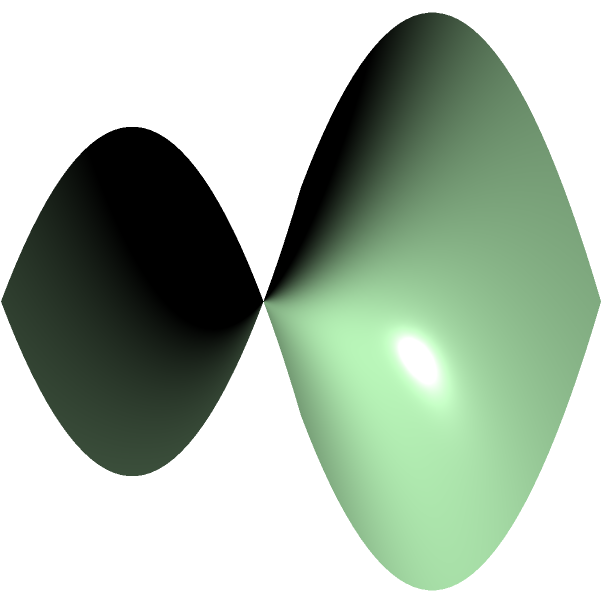In a survival scenario, you encounter a strange landscape reminiscent of a saddle-shaped surface. Two seemingly parallel paths diverge as they traverse this unusual terrain. Given that this surface follows the equation $z = x^2 - y^2$, how would you explain the behavior of these paths to your fellow survivalists? What fundamental principle of Non-Euclidean geometry does this illustrate? To explain this phenomenon to fellow survivalists, follow these steps:

1. Recognize the surface: The equation $z = x^2 - y^2$ describes a hyperbolic paraboloid, commonly known as a saddle surface.

2. Understand parallel lines in Euclidean geometry: In flat (Euclidean) space, parallel lines maintain a constant distance and never intersect.

3. Observe the paths on the saddle surface: The red and blue lines in the diagram represent two paths that would be parallel in flat space.

4. Note the divergence: As these paths traverse the saddle surface, they appear to diverge from each other.

5. Explain the cause: This divergence occurs because the paths follow the curvature of the surface. The surface curves upward in one direction (along the x-axis) and downward in the perpendicular direction (along the y-axis).

6. Relate to Non-Euclidean geometry: This behavior illustrates a fundamental principle of Non-Euclidean geometry - parallel lines can diverge or converge on curved surfaces.

7. Survival context: In a survival situation, this understanding could be crucial for navigation, as straight-line paths on maps might not translate to straight paths in unusually shaped terrains.

8. Conclude with the principle: This phenomenon demonstrates that Euclid's parallel postulate doesn't hold in Non-Euclidean spaces, specifically on negatively curved surfaces like this saddle shape.
Answer: Parallel lines diverge on negatively curved surfaces, violating Euclid's parallel postulate. 